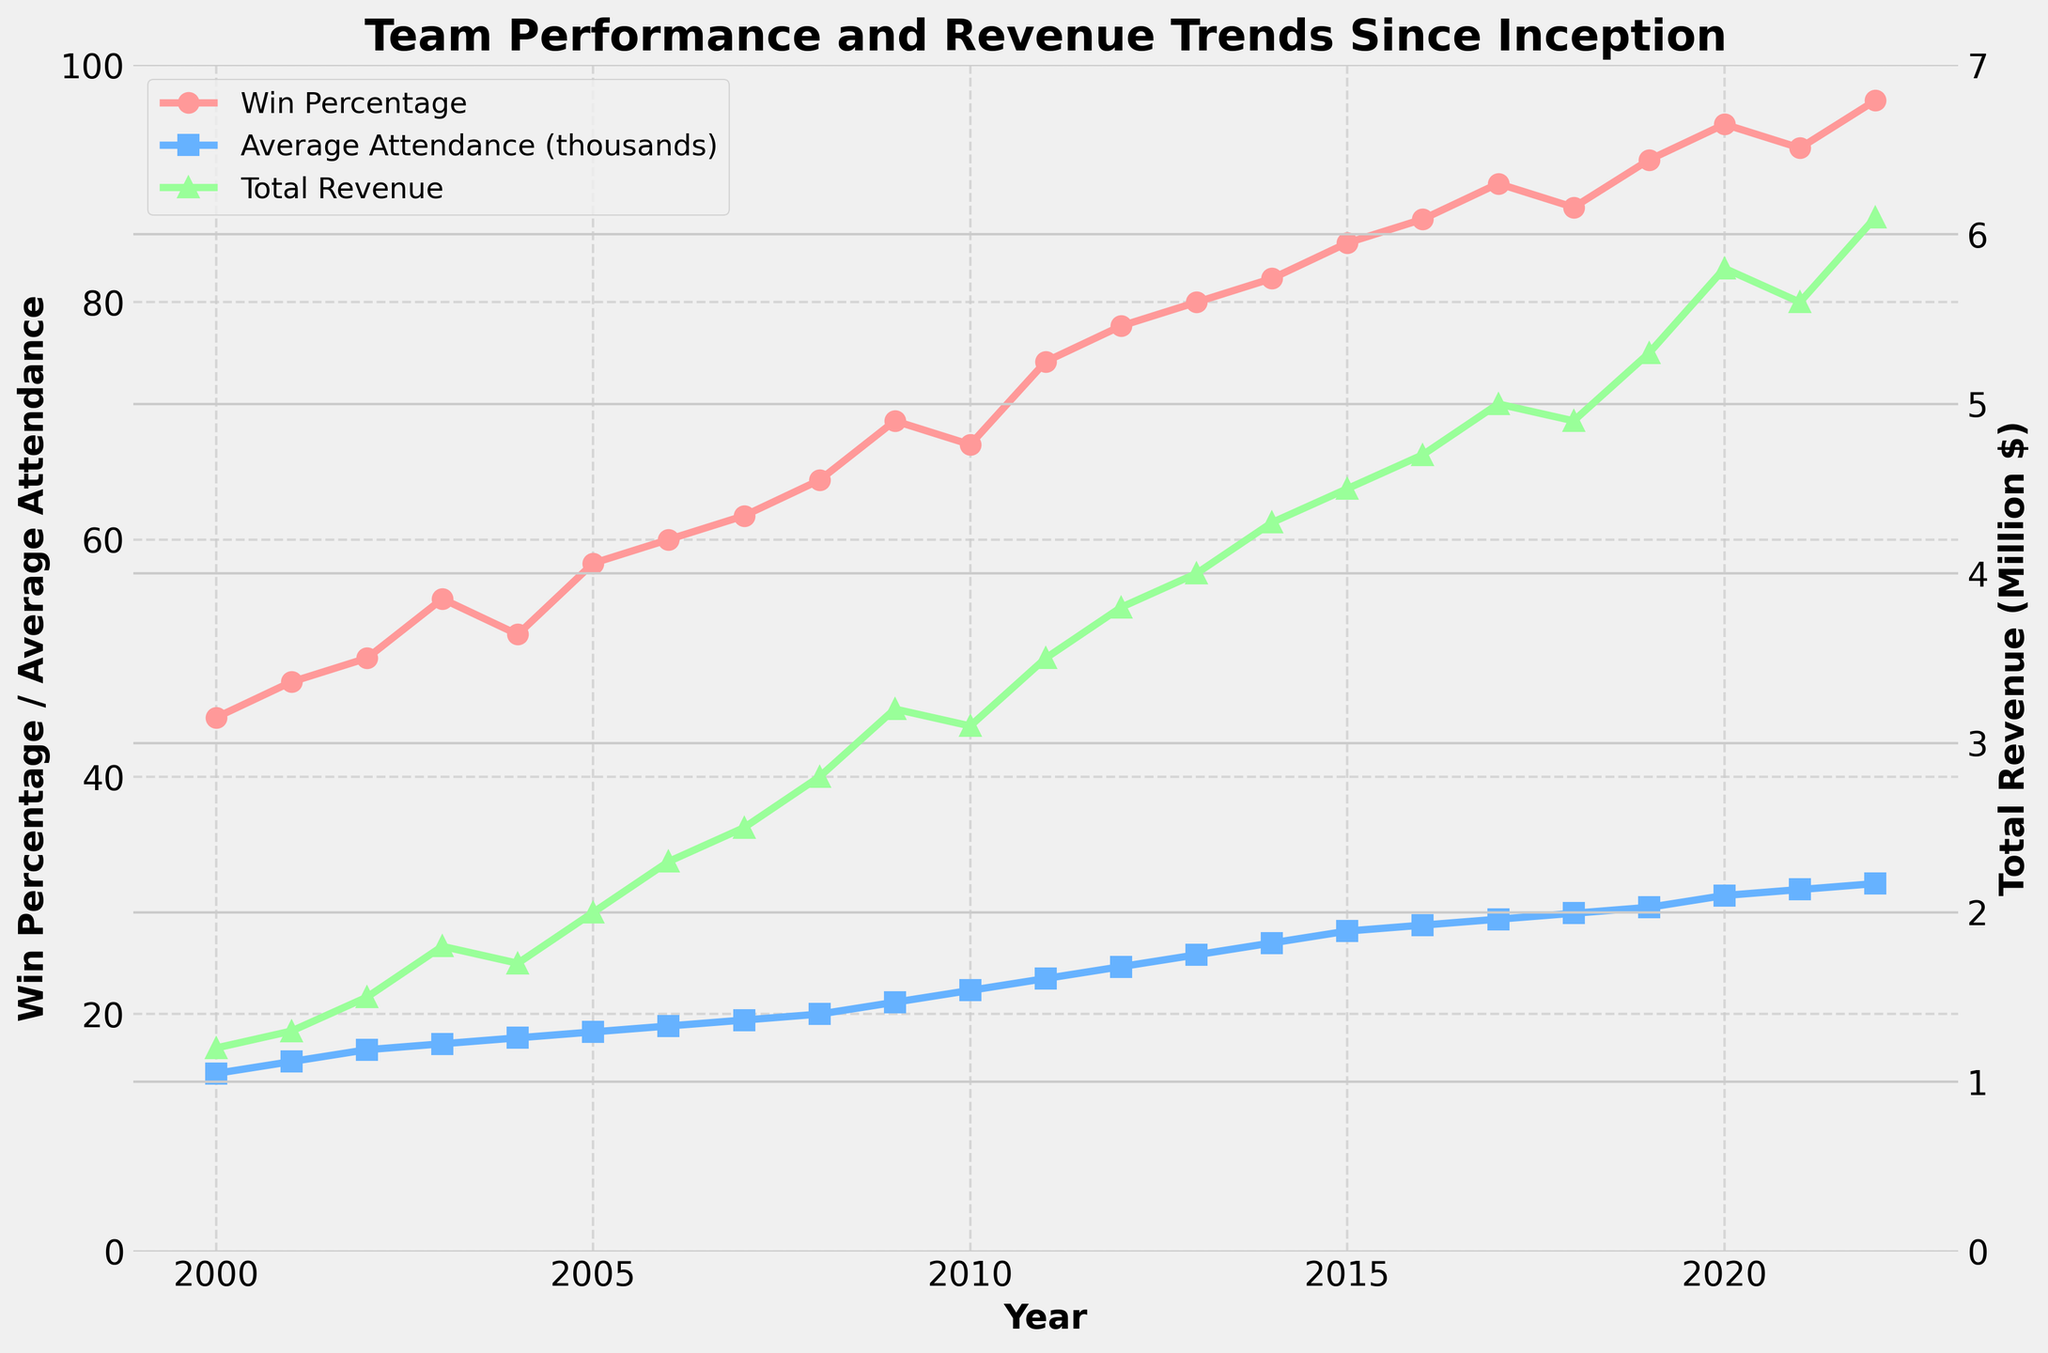What's the title of the plot? The title is located at the top of the plot, usually in a larger and bold font. By inspecting this area, you can read the title directly.
Answer: Team Performance and Revenue Trends Since Inception What is the Win Percentage in 2010? Identify the data point for 2010 on the x-axis and then look vertically to find the corresponding value on the y-axis for Win Percentage.
Answer: 68 In which year did the Average Attendance first reach 30000? Locate the purple line representing Average Attendance, and find the year where it first reaches the 30000 mark on the y-axis.
Answer: 2020 By how much did the Total Revenue increase from 2000 to 2022? Locate the Total Revenue values for the years 2000 and 2022 on the y-axis, then subtract the 2000 value from the 2022 value (6.1 - 1.2).
Answer: 4.9 million dollars Which year saw the highest Win Percentage? Examine the red line representing Win Percentage and determine the highest point, then match it to the corresponding year on the x-axis.
Answer: 2022 What is the relationship between Win Percentage and Total Revenue in 2013? Find the values for both Win Percentage and Total Revenue for the year 2013 and observe how they align; both should show an increasing trend.
Answer: Highly positive, both are high Compare Average Attendance in 2002 and 2020. Which year had higher attendance? Inspect the blue line for Average Attendance values in 2002 and 2020 and compare the y-axis positions.
Answer: 2020 Which year experienced the largest single-year increase in Total Revenue? Identify the largest vertical jump in the green line representing Total Revenue between consecutive years to pinpoint the year.
Answer: 2020 What trend can be observed in Win Percentage and Total Revenue from 2015 to 2022? Observe the general direction of the red and green lines from 2015 to 2022; both lines show a rising trend indicating improved performance and increased revenue.
Answer: Upward trend for both Is there any year where Total Revenue decreased while Win Percentage increased? Scan the plot to see if there's any year where the green line (Total Revenue) dips while the red line (Win Percentage) rises.
Answer: 2021 